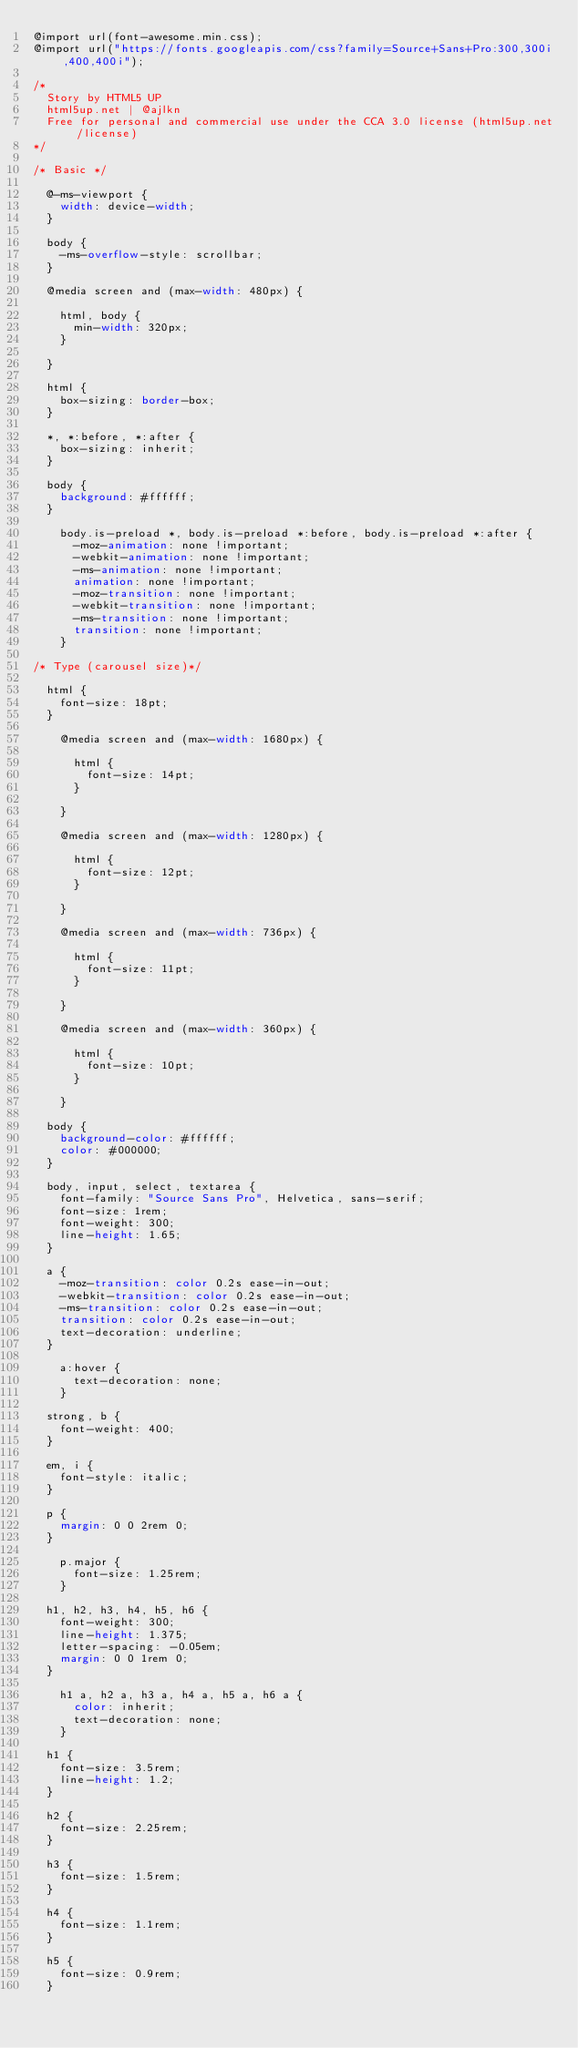Convert code to text. <code><loc_0><loc_0><loc_500><loc_500><_CSS_>@import url(font-awesome.min.css);
@import url("https://fonts.googleapis.com/css?family=Source+Sans+Pro:300,300i,400,400i");

/*
	Story by HTML5 UP
	html5up.net | @ajlkn
	Free for personal and commercial use under the CCA 3.0 license (html5up.net/license)
*/

/* Basic */

	@-ms-viewport {
		width: device-width;
	}

	body {
		-ms-overflow-style: scrollbar;
	}

	@media screen and (max-width: 480px) {

		html, body {
			min-width: 320px;
		}

	}

	html {
		box-sizing: border-box;
	}

	*, *:before, *:after {
		box-sizing: inherit;
	}

	body {
		background: #ffffff;
	}

		body.is-preload *, body.is-preload *:before, body.is-preload *:after {
			-moz-animation: none !important;
			-webkit-animation: none !important;
			-ms-animation: none !important;
			animation: none !important;
			-moz-transition: none !important;
			-webkit-transition: none !important;
			-ms-transition: none !important;
			transition: none !important;
		}

/* Type (carousel size)*/

	html {
		font-size: 18pt;
	}

		@media screen and (max-width: 1680px) {

			html {
				font-size: 14pt;
			}

		}

		@media screen and (max-width: 1280px) {

			html {
				font-size: 12pt;
			}

		}

		@media screen and (max-width: 736px) {

			html {
				font-size: 11pt;
			}

		}

		@media screen and (max-width: 360px) {

			html {
				font-size: 10pt;
			}

		}

	body {
		background-color: #ffffff;
		color: #000000;
	}

	body, input, select, textarea {
		font-family: "Source Sans Pro", Helvetica, sans-serif;
		font-size: 1rem;
		font-weight: 300;
		line-height: 1.65;
	}

	a {
		-moz-transition: color 0.2s ease-in-out;
		-webkit-transition: color 0.2s ease-in-out;
		-ms-transition: color 0.2s ease-in-out;
		transition: color 0.2s ease-in-out;
		text-decoration: underline;
	}

		a:hover {
			text-decoration: none;
		}

	strong, b {
		font-weight: 400;
	}

	em, i {
		font-style: italic;
	}

	p {
		margin: 0 0 2rem 0;
	}

		p.major {
			font-size: 1.25rem;
		}

	h1, h2, h3, h4, h5, h6 {
		font-weight: 300;
		line-height: 1.375;
		letter-spacing: -0.05em;
		margin: 0 0 1rem 0;
	}

		h1 a, h2 a, h3 a, h4 a, h5 a, h6 a {
			color: inherit;
			text-decoration: none;
		}

	h1 {
		font-size: 3.5rem;
		line-height: 1.2;
	}

	h2 {
		font-size: 2.25rem;
	}

	h3 {
		font-size: 1.5rem;
	}

	h4 {
		font-size: 1.1rem;
	}

	h5 {
		font-size: 0.9rem;
	}
</code> 